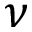Convert formula to latex. <formula><loc_0><loc_0><loc_500><loc_500>\nu</formula> 